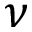Convert formula to latex. <formula><loc_0><loc_0><loc_500><loc_500>\nu</formula> 